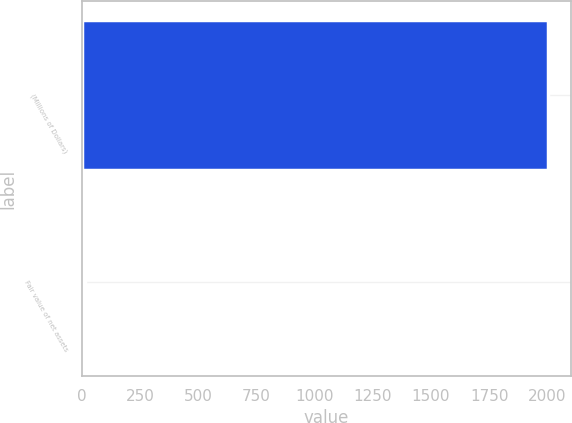<chart> <loc_0><loc_0><loc_500><loc_500><bar_chart><fcel>(Millions of Dollars)<fcel>Fair value of net assets<nl><fcel>2003<fcel>15<nl></chart> 